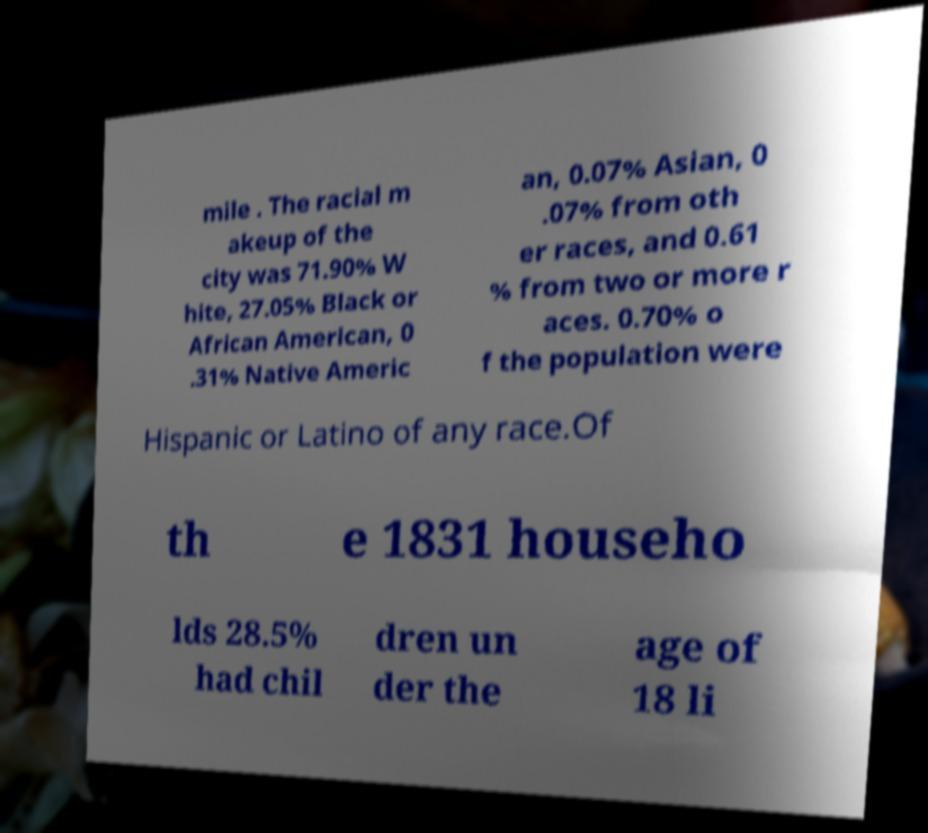For documentation purposes, I need the text within this image transcribed. Could you provide that? mile . The racial m akeup of the city was 71.90% W hite, 27.05% Black or African American, 0 .31% Native Americ an, 0.07% Asian, 0 .07% from oth er races, and 0.61 % from two or more r aces. 0.70% o f the population were Hispanic or Latino of any race.Of th e 1831 househo lds 28.5% had chil dren un der the age of 18 li 